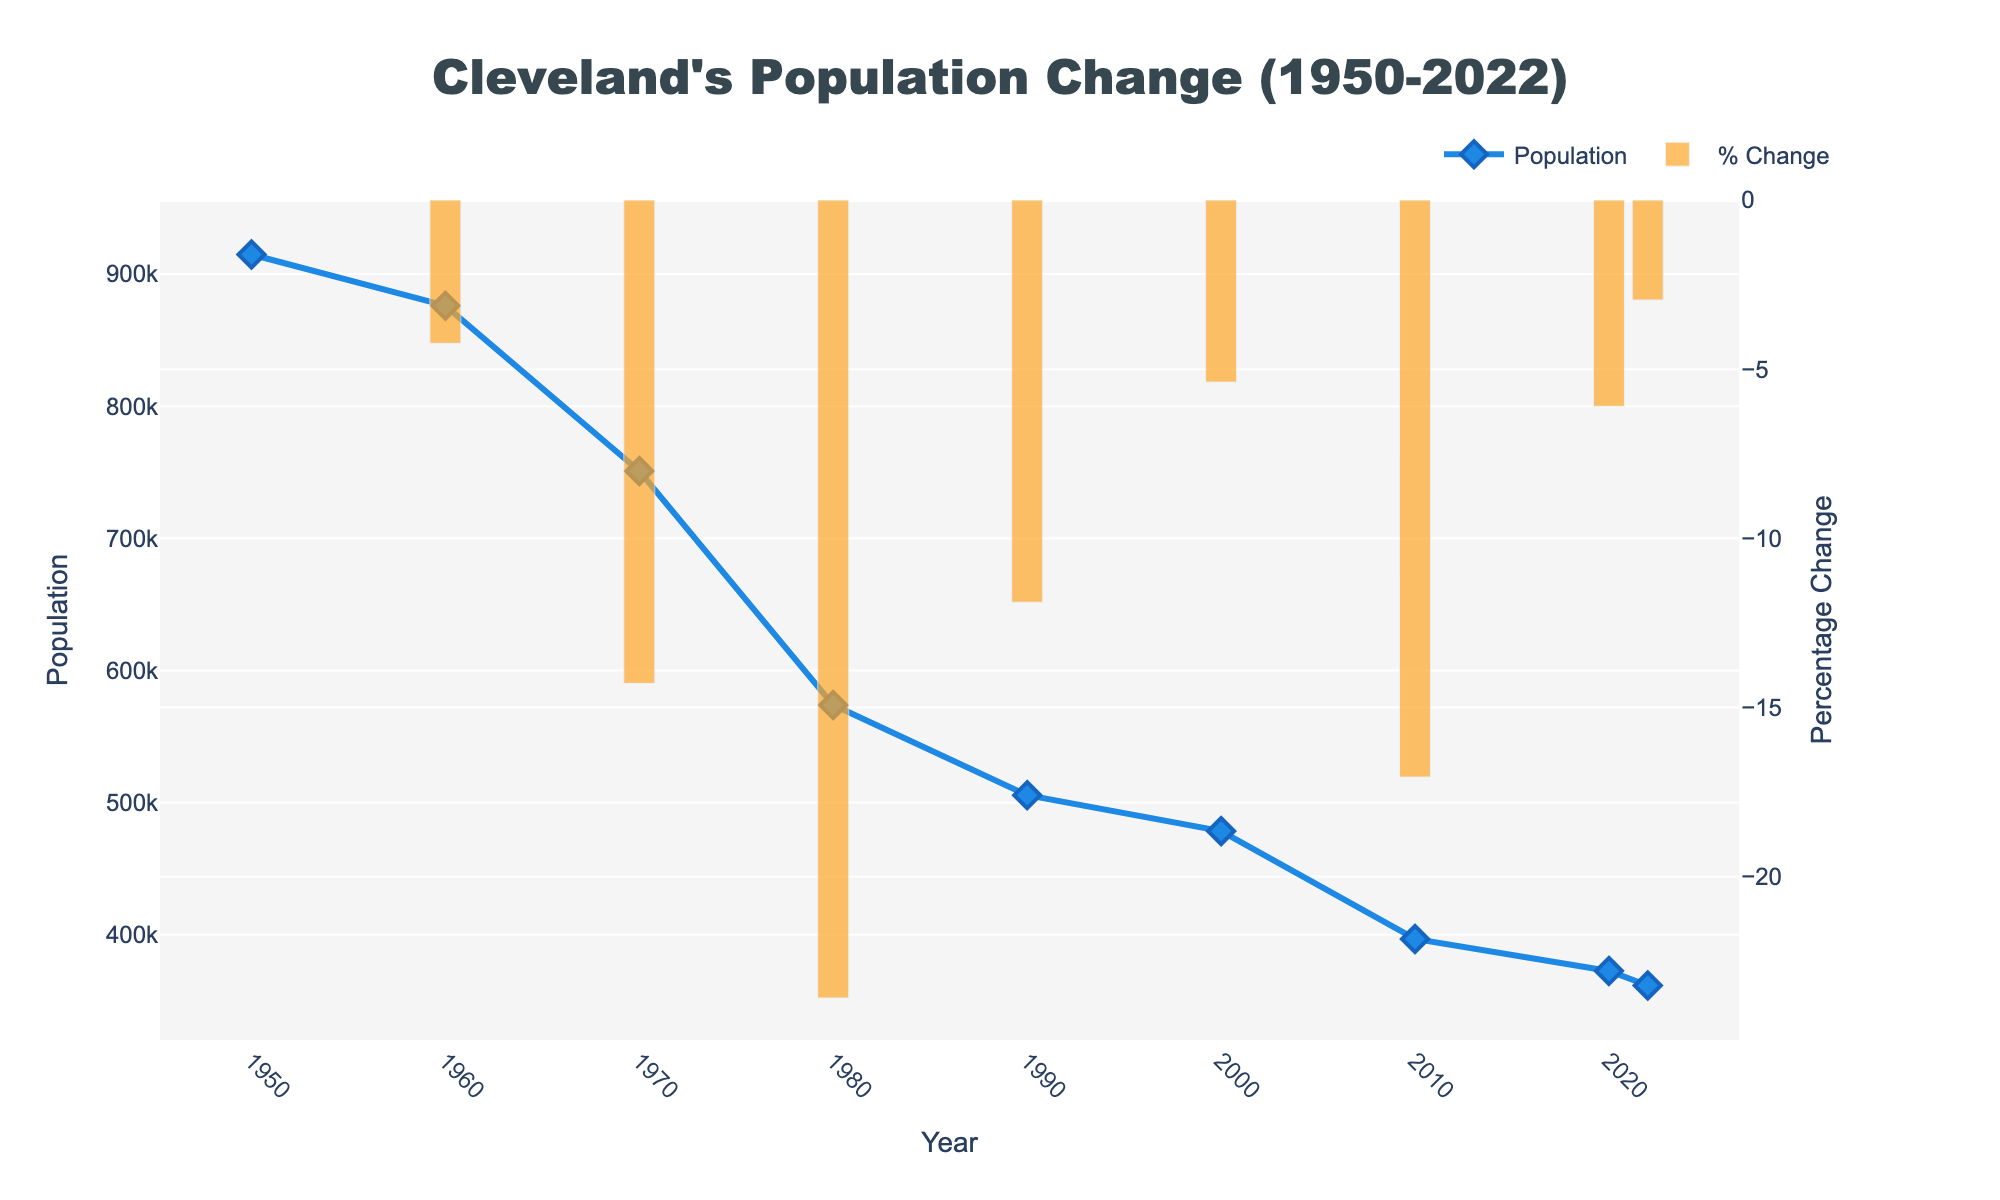What is the trend of Cleveland's population from 1950 to the present? The figure shows a consistent decline in Cleveland's population from 1950, with a population peak at around 914,808, steadily decreasing to 361,607 in 2022.
Answer: Declining In which decade did Cleveland's population experience the largest decline based on the figure? To determine the largest decline, visually inspect the year-to-year changes in the figure. The biggest drop appears between 1970 and 1980, with the population falling from approximately 750,903 to 573,822.
Answer: 1970-1980 Which year marks the beginning of Cleveland's highest recorded population in the figure? The population line peaks at the leftmost point of the figure, indicating the highest recorded population was in the year 1950.
Answer: 1950 What is the approximate percentage change in population from 2000 to 2010? Refer to the bar corresponding to 2010 in the second trace (% Change). The percentage change is negative, indicating a decline, with an approximate value of around -17%.
Answer: -17% How does the population percentage change in 2020 compare to 2022? Inspect the height of the bars for 2020 and 2022. Both bars indicate a decrease, but the bar in 2022 is slightly shorter than in 2020, suggesting a smaller percentage decline in population from 2020 to 2022.
Answer: Smaller percentage decline What is the population difference between the years 1960 and 1980? The population in 1960 was approximately 876,050, and in 1980 it was around 573,822. Subtracting these gives 876,050 - 573,822 = 302,228.
Answer: 302,228 Between which two consecutive decades does the figure show a slight decrease in the rate of population decline? Looking at the slope of the population line and the height of the percentage change bars, from 2010 to 2020, there is a smaller decline compared to previous decades.
Answer: 2010-2020 How many times has Cleveland's population decreased over the analysis period? The line chart shows decreasing values in population for each marked year from 1950 to 2022, meaning the population decreased every time. Count the number of years to see 8 decreases.
Answer: 8 times 